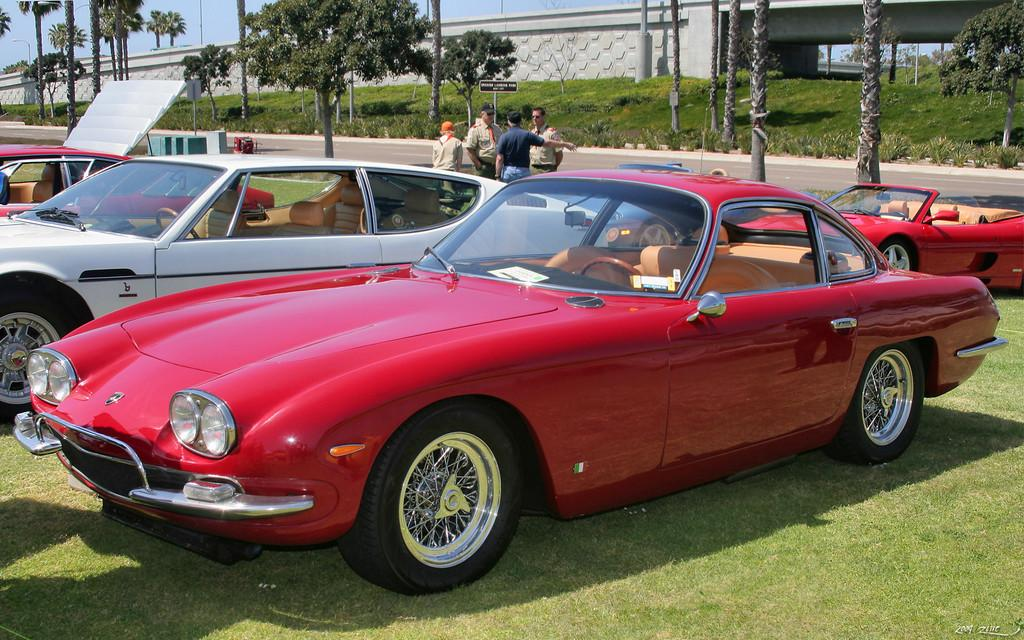What color is the car in the image? The car in the image is red. Where is the car located in the image? The car is on the grass. What can be seen in the background of the image? There are other cars, people, trees, a bridge, a road, and the sky visible in the background of the image. What type of powder is being used to clean the drain in the image? There is no drain or powder present in the image. 